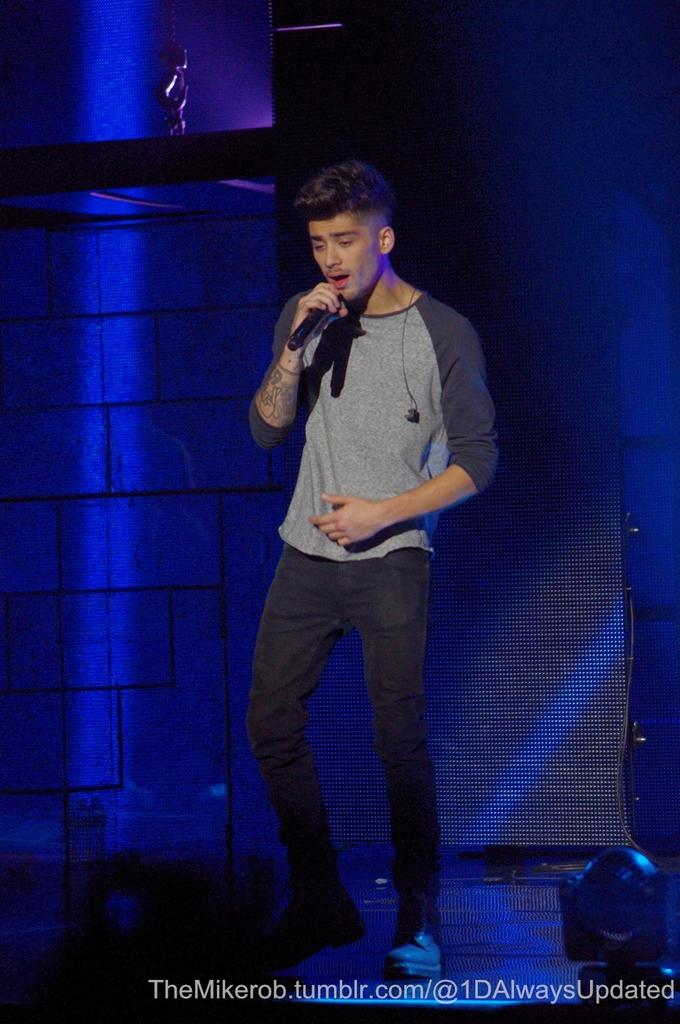What is the main subject of the image? The main subject of the image is a man standing in the middle of the image. What is the man holding in the image? The man is holding a microphone. What is located behind the man in the image? There is a wall behind the man. What type of throat lozenge is the man holding in the image? The man is not holding a throat lozenge in the image; he is holding a microphone. What type of sack is visible on the wall behind the man? There is no sack visible on the wall behind the man in the image. 